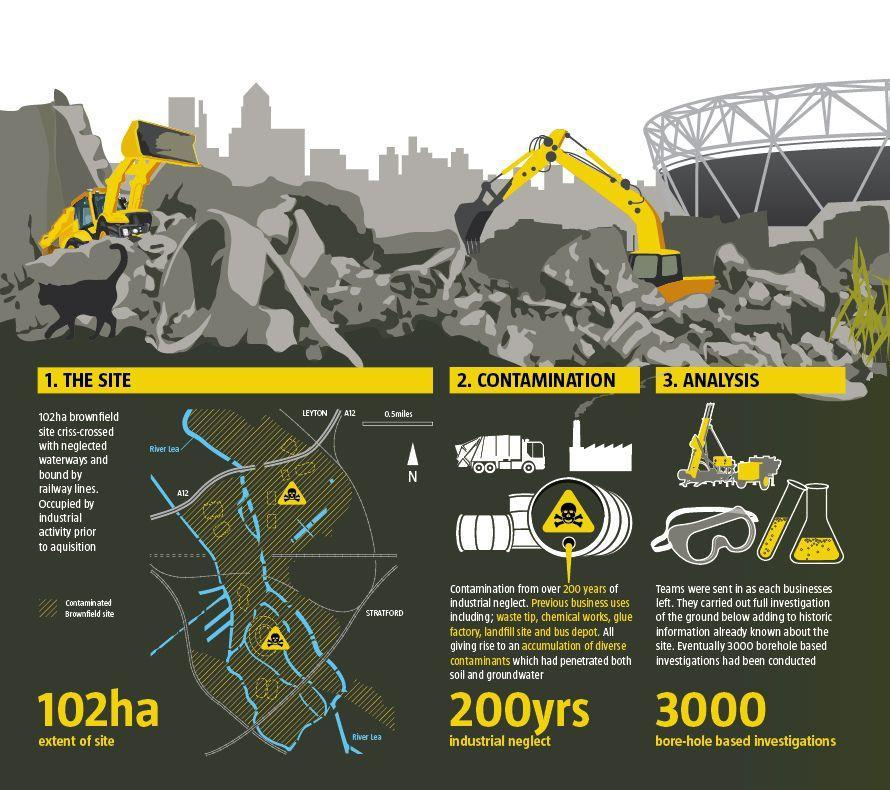What is the extent of the site?
Answer the question with a short phrase. 102ha 